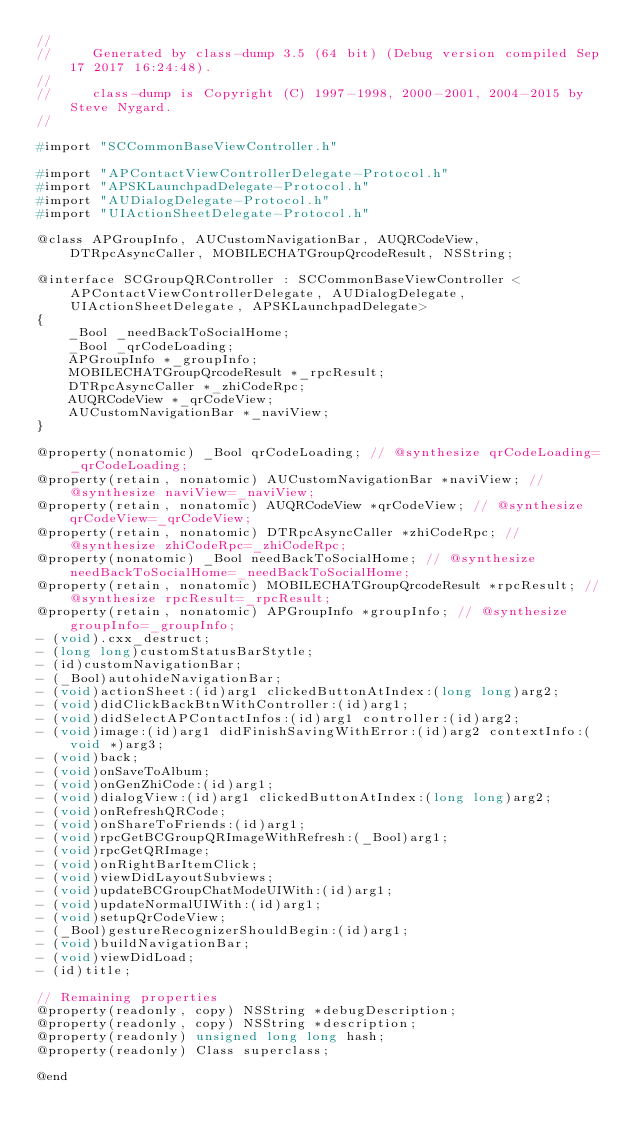<code> <loc_0><loc_0><loc_500><loc_500><_C_>//
//     Generated by class-dump 3.5 (64 bit) (Debug version compiled Sep 17 2017 16:24:48).
//
//     class-dump is Copyright (C) 1997-1998, 2000-2001, 2004-2015 by Steve Nygard.
//

#import "SCCommonBaseViewController.h"

#import "APContactViewControllerDelegate-Protocol.h"
#import "APSKLaunchpadDelegate-Protocol.h"
#import "AUDialogDelegate-Protocol.h"
#import "UIActionSheetDelegate-Protocol.h"

@class APGroupInfo, AUCustomNavigationBar, AUQRCodeView, DTRpcAsyncCaller, MOBILECHATGroupQrcodeResult, NSString;

@interface SCGroupQRController : SCCommonBaseViewController <APContactViewControllerDelegate, AUDialogDelegate, UIActionSheetDelegate, APSKLaunchpadDelegate>
{
    _Bool _needBackToSocialHome;
    _Bool _qrCodeLoading;
    APGroupInfo *_groupInfo;
    MOBILECHATGroupQrcodeResult *_rpcResult;
    DTRpcAsyncCaller *_zhiCodeRpc;
    AUQRCodeView *_qrCodeView;
    AUCustomNavigationBar *_naviView;
}

@property(nonatomic) _Bool qrCodeLoading; // @synthesize qrCodeLoading=_qrCodeLoading;
@property(retain, nonatomic) AUCustomNavigationBar *naviView; // @synthesize naviView=_naviView;
@property(retain, nonatomic) AUQRCodeView *qrCodeView; // @synthesize qrCodeView=_qrCodeView;
@property(retain, nonatomic) DTRpcAsyncCaller *zhiCodeRpc; // @synthesize zhiCodeRpc=_zhiCodeRpc;
@property(nonatomic) _Bool needBackToSocialHome; // @synthesize needBackToSocialHome=_needBackToSocialHome;
@property(retain, nonatomic) MOBILECHATGroupQrcodeResult *rpcResult; // @synthesize rpcResult=_rpcResult;
@property(retain, nonatomic) APGroupInfo *groupInfo; // @synthesize groupInfo=_groupInfo;
- (void).cxx_destruct;
- (long long)customStatusBarStytle;
- (id)customNavigationBar;
- (_Bool)autohideNavigationBar;
- (void)actionSheet:(id)arg1 clickedButtonAtIndex:(long long)arg2;
- (void)didClickBackBtnWithController:(id)arg1;
- (void)didSelectAPContactInfos:(id)arg1 controller:(id)arg2;
- (void)image:(id)arg1 didFinishSavingWithError:(id)arg2 contextInfo:(void *)arg3;
- (void)back;
- (void)onSaveToAlbum;
- (void)onGenZhiCode:(id)arg1;
- (void)dialogView:(id)arg1 clickedButtonAtIndex:(long long)arg2;
- (void)onRefreshQRCode;
- (void)onShareToFriends:(id)arg1;
- (void)rpcGetBCGroupQRImageWithRefresh:(_Bool)arg1;
- (void)rpcGetQRImage;
- (void)onRightBarItemClick;
- (void)viewDidLayoutSubviews;
- (void)updateBCGroupChatModeUIWith:(id)arg1;
- (void)updateNormalUIWith:(id)arg1;
- (void)setupQrCodeView;
- (_Bool)gestureRecognizerShouldBegin:(id)arg1;
- (void)buildNavigationBar;
- (void)viewDidLoad;
- (id)title;

// Remaining properties
@property(readonly, copy) NSString *debugDescription;
@property(readonly, copy) NSString *description;
@property(readonly) unsigned long long hash;
@property(readonly) Class superclass;

@end

</code> 